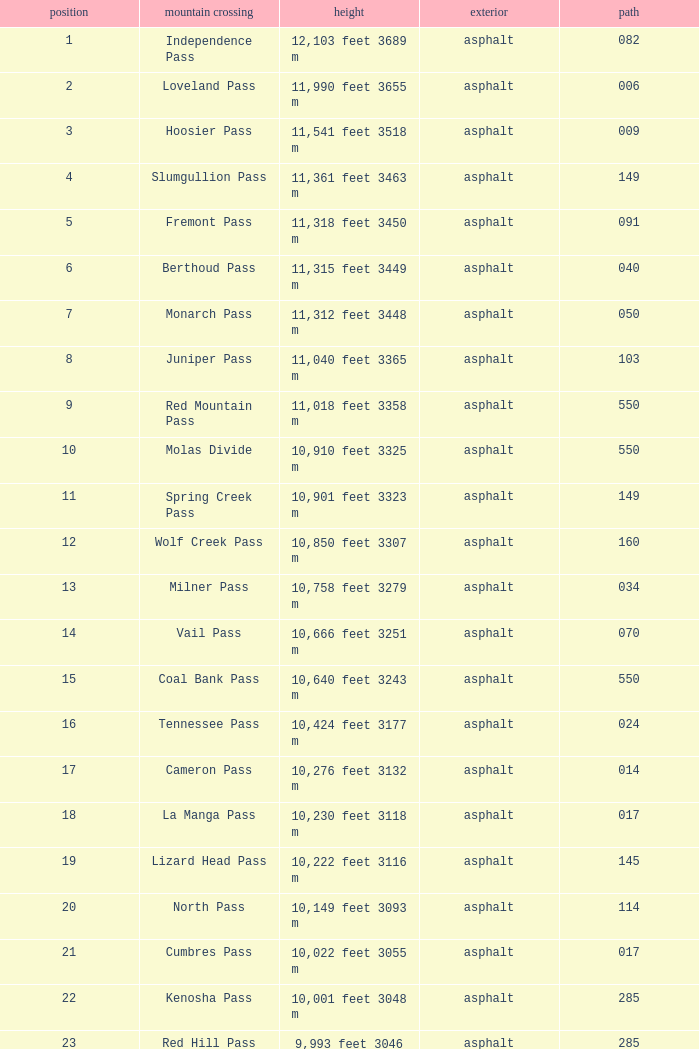What Mountain Pass has an Elevation of 10,001 feet 3048 m? Kenosha Pass. 